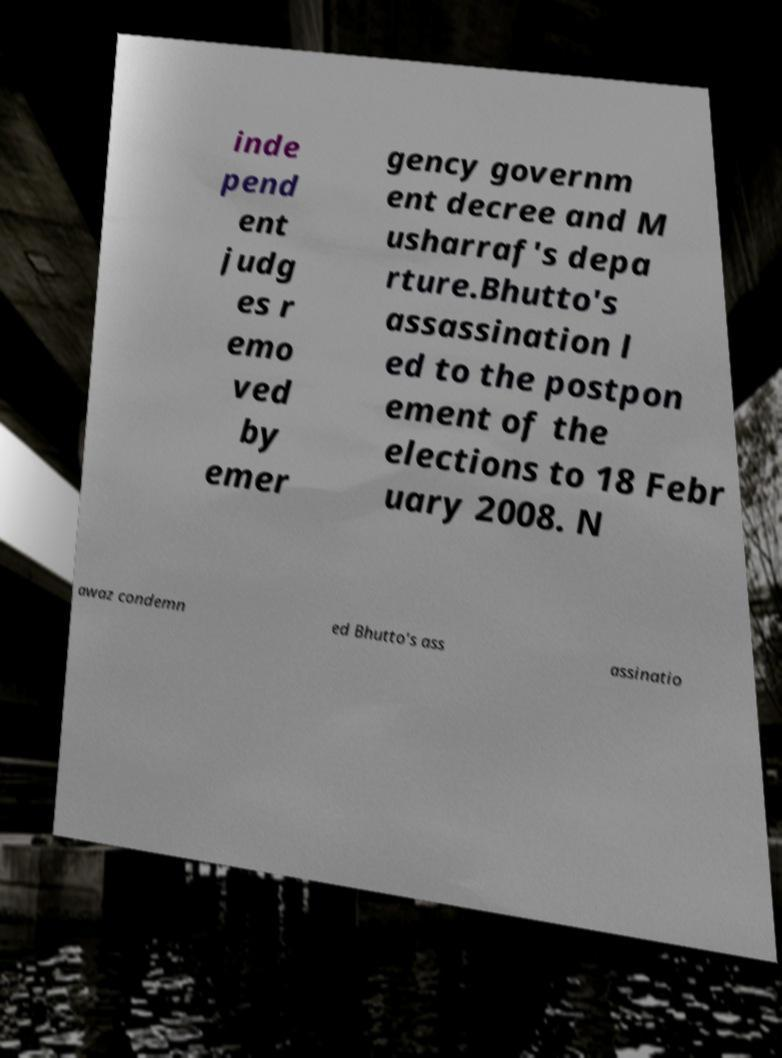Can you accurately transcribe the text from the provided image for me? inde pend ent judg es r emo ved by emer gency governm ent decree and M usharraf's depa rture.Bhutto's assassination l ed to the postpon ement of the elections to 18 Febr uary 2008. N awaz condemn ed Bhutto's ass assinatio 